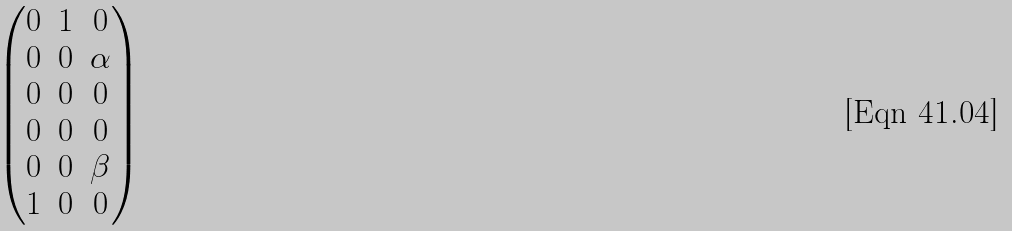<formula> <loc_0><loc_0><loc_500><loc_500>\begin{pmatrix} 0 & 1 & 0 \\ 0 & 0 & \alpha \\ 0 & 0 & 0 \\ 0 & 0 & 0 \\ 0 & 0 & \beta \\ 1 & 0 & 0 \end{pmatrix}</formula> 